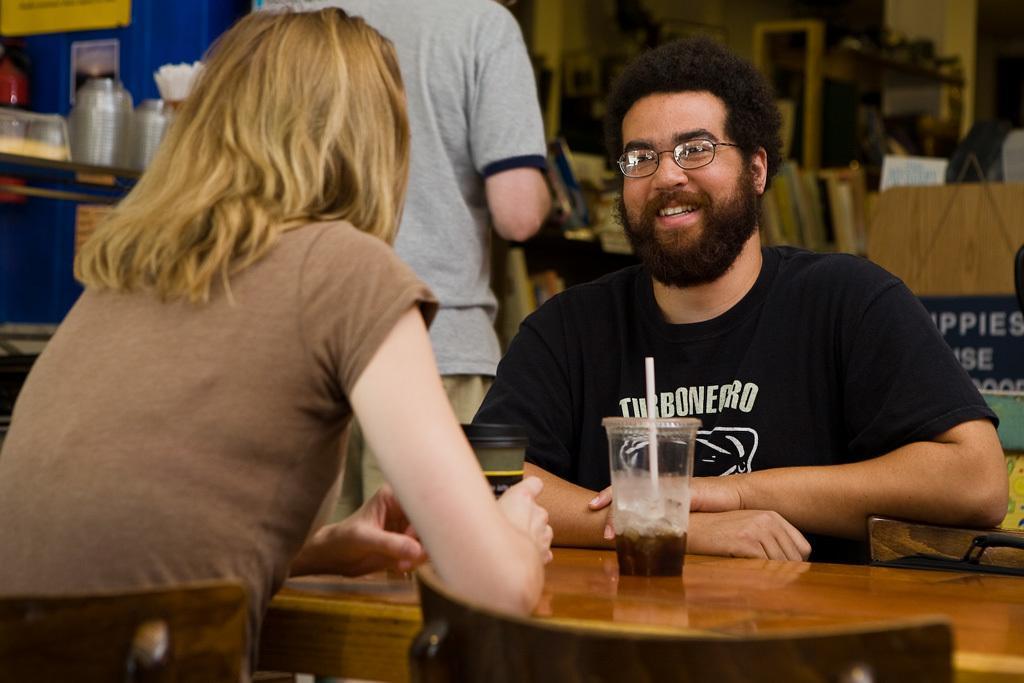How would you summarize this image in a sentence or two? In the picture we can find a table, one man,woman. In the background we can find one man standing and we can see some books, jars, table and on the table we can find a glass, straw in the glass, A man sitting on a chair is wearing a black T-shirt with beard and the woman is wearing a T-shirt and she is with golden hair. 